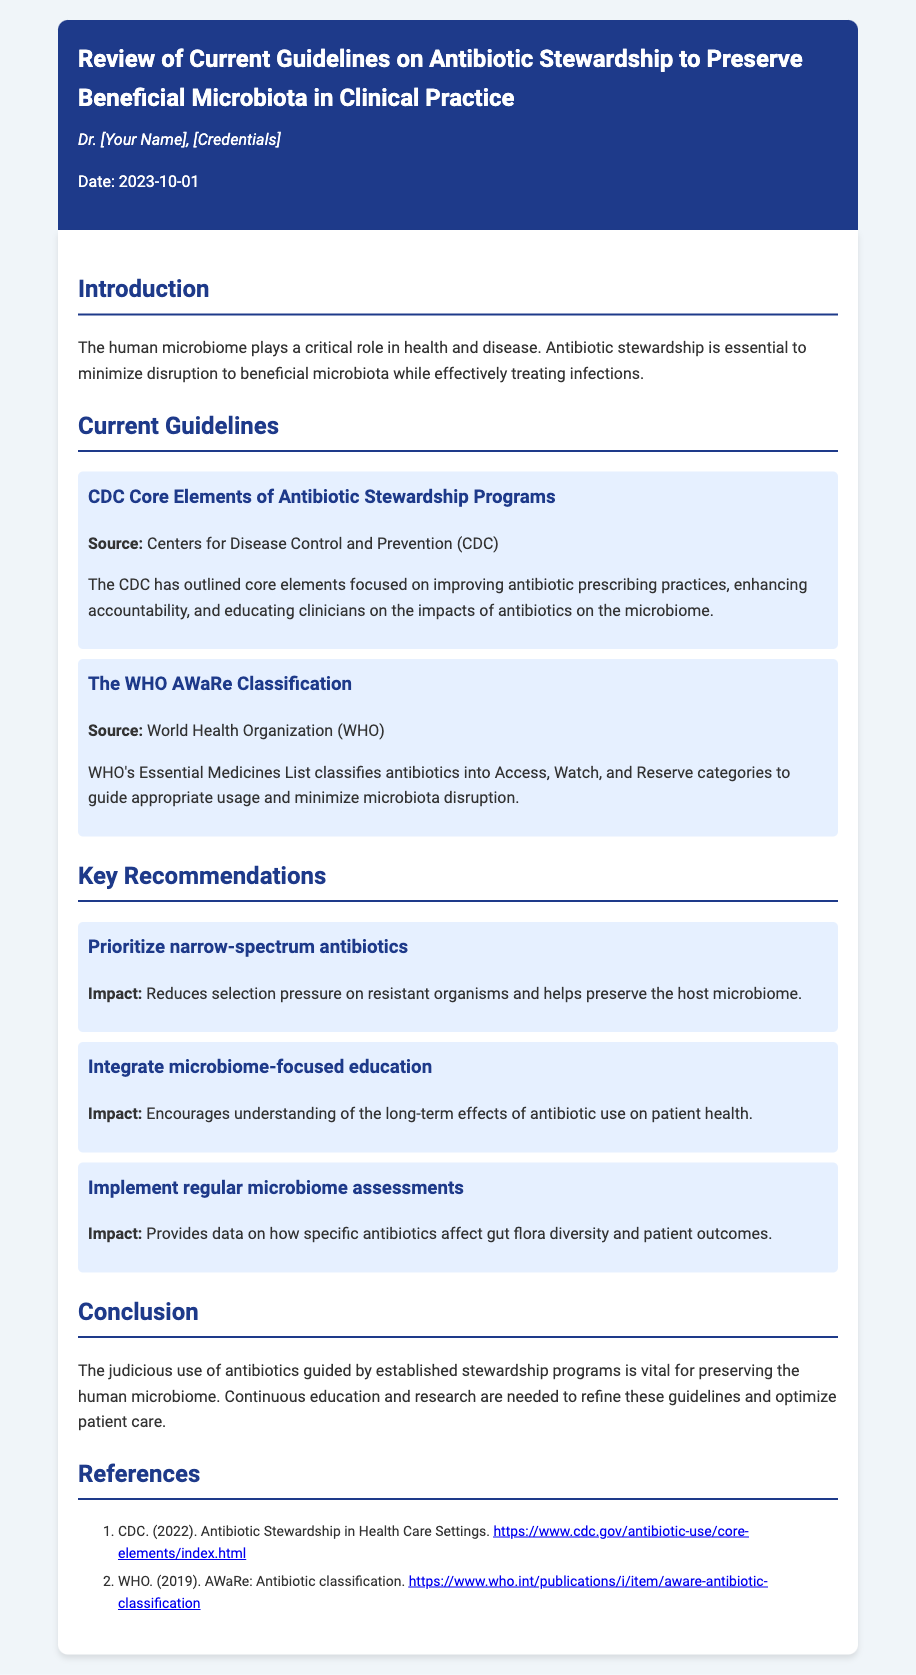what is the title of the memo? The title of the memo is found in the header section of the document.
Answer: Review of Current Guidelines on Antibiotic Stewardship to Preserve Beneficial Microbiota in Clinical Practice who authored the memo? The author's name appears below the title in the memo header.
Answer: Dr. [Your Name], [Credentials] what date was the memo written? The date of the memo is stated in the memo header.
Answer: 2023-10-01 what organization provided the core elements of antibiotic stewardship programs? The source of the core elements is mentioned in the guidelines section.
Answer: Centers for Disease Control and Prevention (CDC) what is the first key recommendation in the memo? The key recommendations are listed under their respective headings, and the first one is specified.
Answer: Prioritize narrow-spectrum antibiotics which guideline focuses on antibiotic classification? The document specifies different guidelines along with their focus areas.
Answer: The WHO AWaRe Classification what is one suggested impact of microbiome-focused education? The impacts of the recommendations are included in their descriptions.
Answer: Encourages understanding of the long-term effects of antibiotic use on patient health what is the main conclusion of the memo? The conclusion summarizes the overall message provided in the memo.
Answer: The judicious use of antibiotics guided by established stewardship programs is vital for preserving the human microbiome how many references are listed in the document? The references are enumerated in a list at the end of the memo.
Answer: 2 